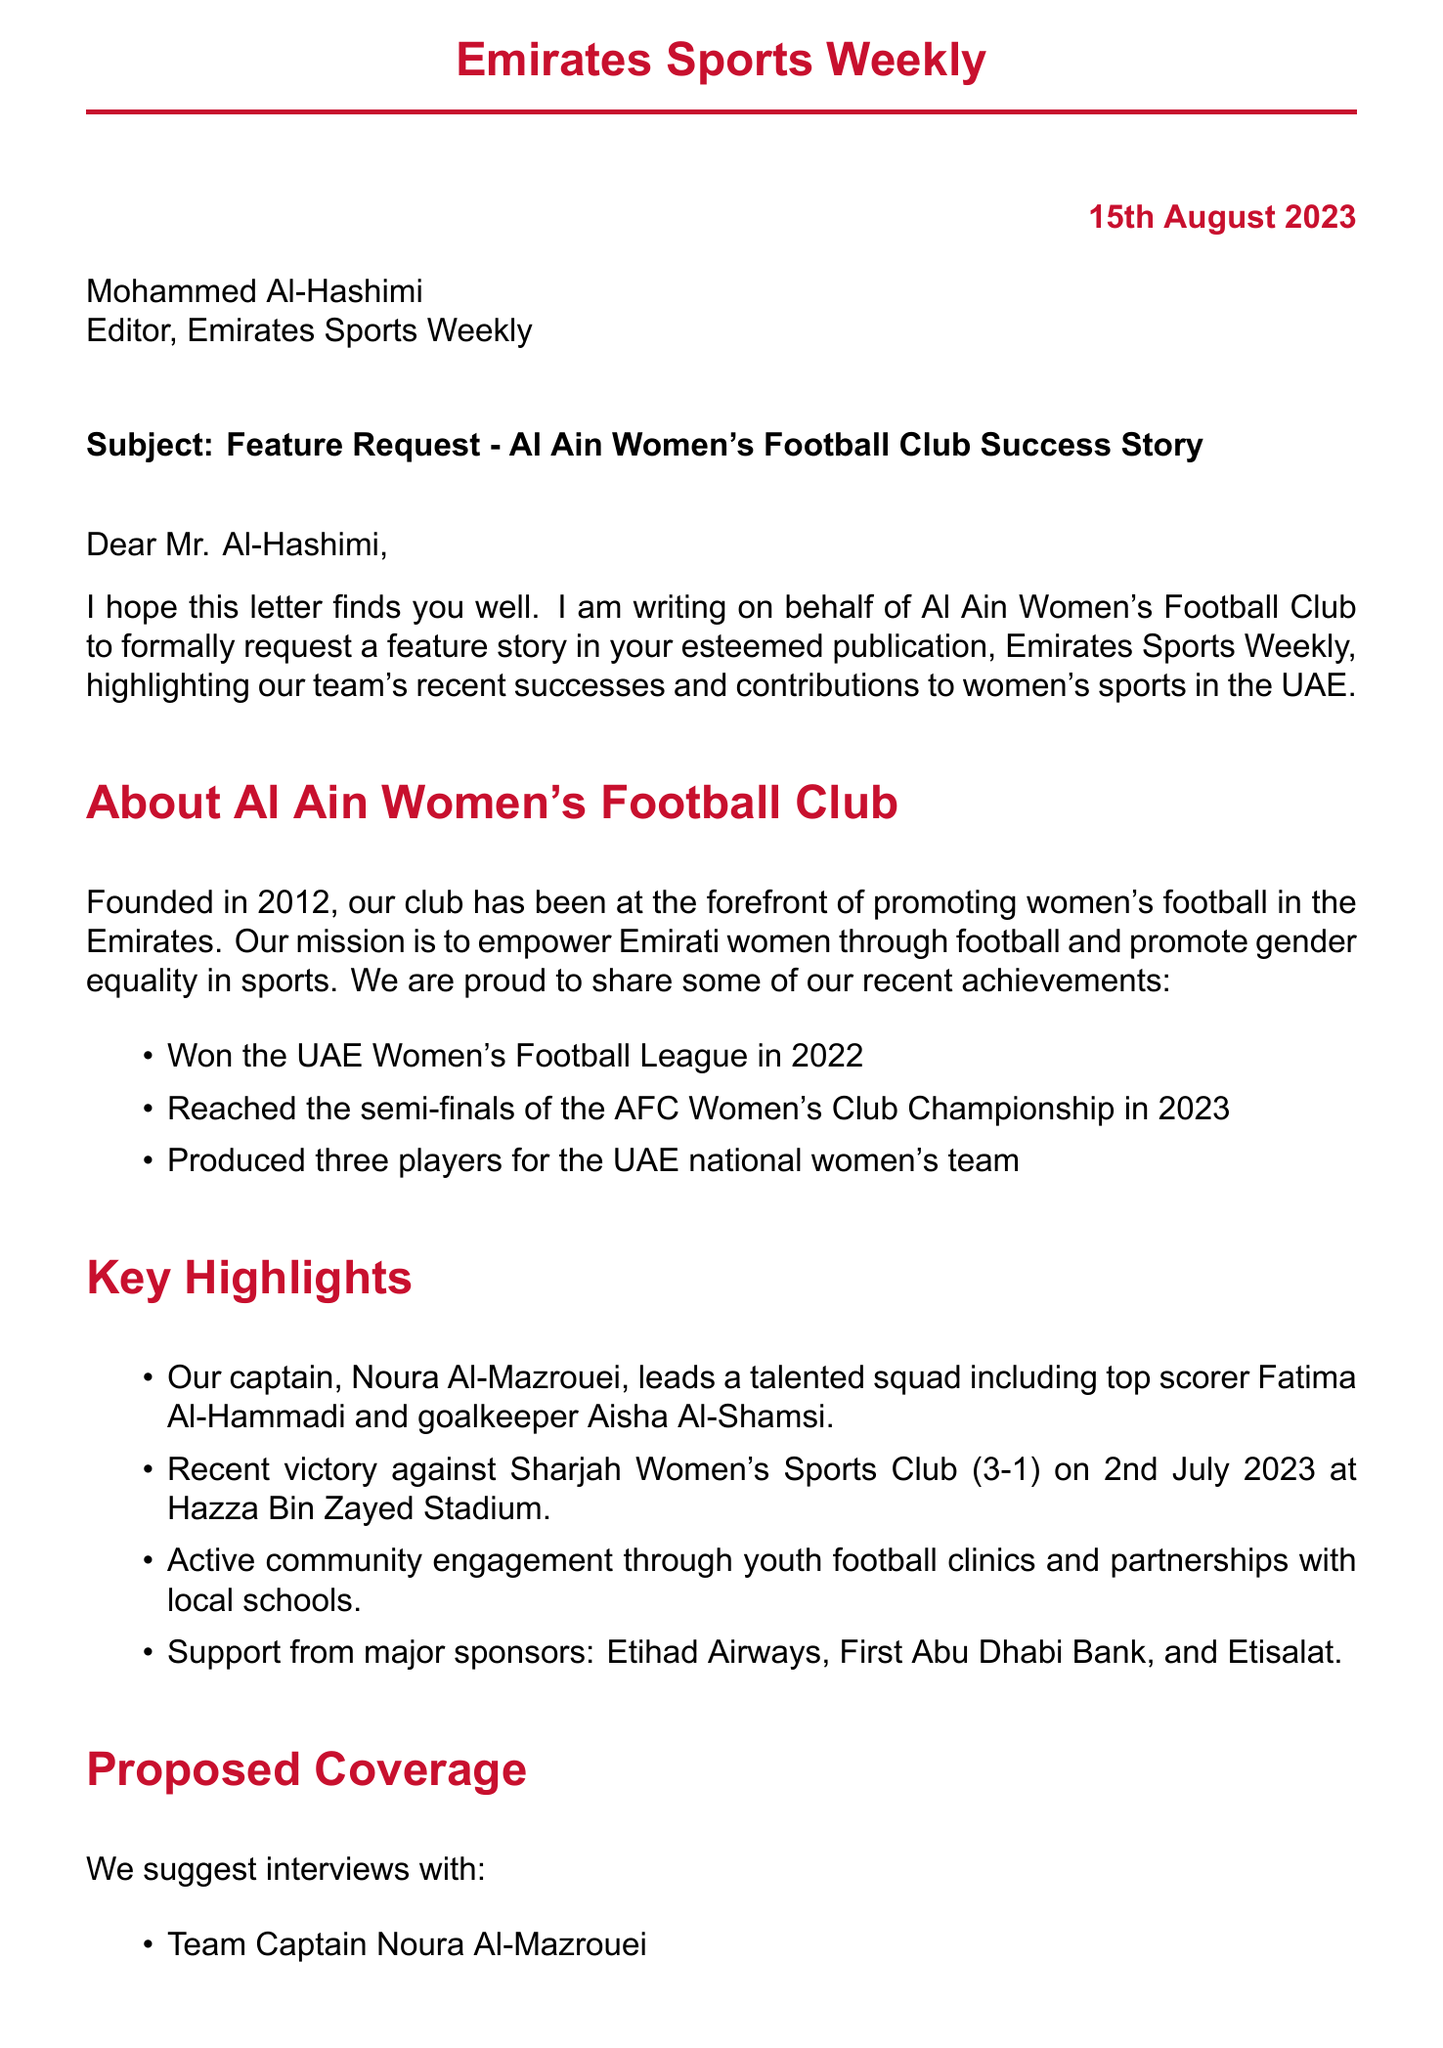What is the name of the women's football club? The letter introduces Al Ain Women's Football Club as the subject of the feature request.
Answer: Al Ain Women's Football Club Who is the team captain? The letter states that Noura Al-Mazrouei is the captain of the team.
Answer: Noura Al-Mazrouei What year was the club founded? The letter mentions that Al Ain Women's Football Club was founded in 2012.
Answer: 2012 What was the score of the recent match against Sharjah Women's Sports Club? The letter specifies the match score against Sharjah Women's Sports Club as 3-1.
Answer: 3-1 Who is the coach of the team? The letter identifies Sarah Thompson as the coach of Al Ain Women's Football Club.
Answer: Sarah Thompson What is the mission of the club? The letter describes the club's mission as empowering Emirati women through football and promoting gender equality in sports.
Answer: Empowering Emirati women through football and promoting gender equality in sports What are the key future goals of the team? The letter outlines goals such as winning the AFC Women's Club Championship and establishing a youth academy.
Answer: Win the AFC Women's Club Championship What publication is the letter addressed to? The letter is directed to Emirates Sports Weekly as the desired publication for the feature story.
Answer: Emirates Sports Weekly Who is the contact person for further information? The letter provides the name of Mariam Al-Suwaidi as the Media Coordinator for contact.
Answer: Mariam Al-Suwaidi 